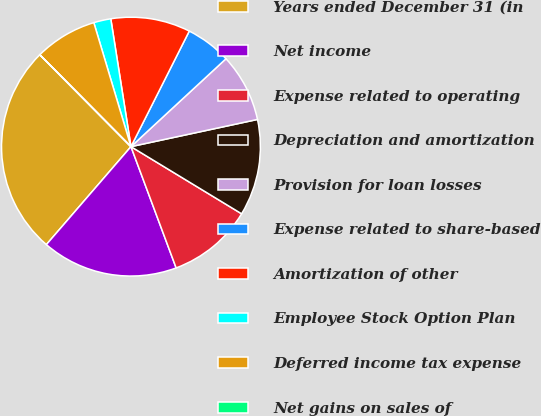Convert chart. <chart><loc_0><loc_0><loc_500><loc_500><pie_chart><fcel>Years ended December 31 (in<fcel>Net income<fcel>Expense related to operating<fcel>Depreciation and amortization<fcel>Provision for loan losses<fcel>Expense related to share-based<fcel>Amortization of other<fcel>Employee Stock Option Plan<fcel>Deferred income tax expense<fcel>Net gains on sales of<nl><fcel>26.22%<fcel>17.01%<fcel>10.64%<fcel>12.05%<fcel>8.51%<fcel>5.68%<fcel>9.93%<fcel>2.14%<fcel>7.8%<fcel>0.01%<nl></chart> 